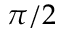<formula> <loc_0><loc_0><loc_500><loc_500>\pi / 2</formula> 